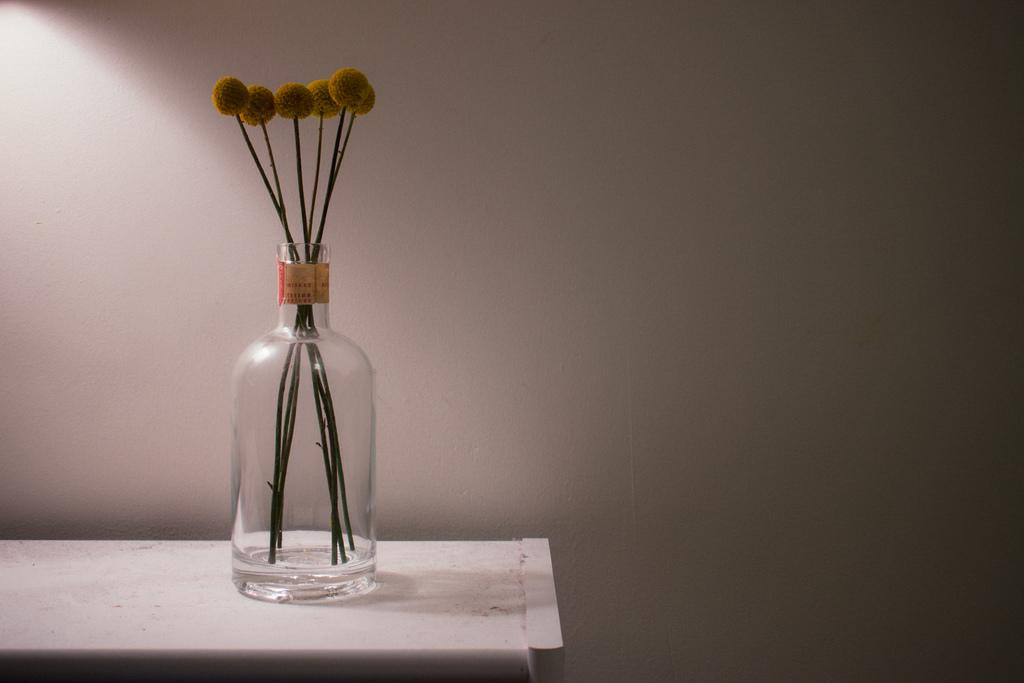What is the main object in the image? There is a glass jar in the image. Where is the glass jar located? The glass jar is on a table. What can be found inside the glass jar? There are objects inside the glass jar. What direction is the toy facing inside the glass jar? There is no toy present in the image, so it is not possible to determine the direction it might be facing. 